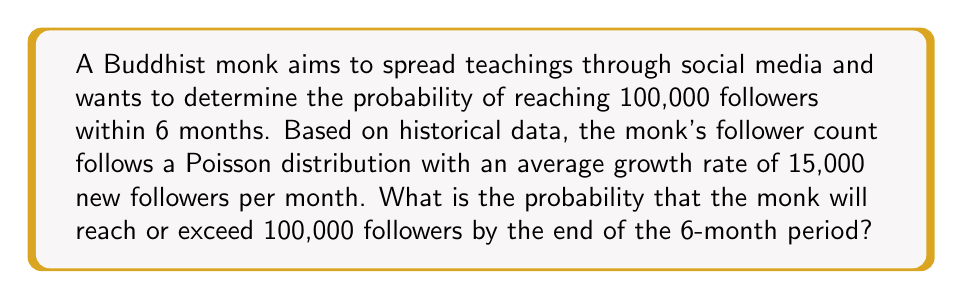Could you help me with this problem? Let's approach this step-by-step:

1) The Poisson distribution models the number of events in a fixed interval of time. In this case, we're looking at the number of new followers over 6 months.

2) The average number of new followers over 6 months is:
   $\lambda = 15,000 \times 6 = 90,000$

3) We want to find the probability of getting at least 100,000 followers. This is equivalent to finding the probability of getting 100,000 or more new followers.

4) The probability of getting exactly $k$ new followers is given by the Poisson probability mass function:

   $$P(X = k) = \frac{e^{-\lambda} \lambda^k}{k!}$$

5) We want $P(X \geq 100,000)$, which is equal to $1 - P(X < 100,000)$

6) In a Poisson distribution, $P(X < x)$ can be approximated using the normal distribution when $\lambda$ is large (which it is in this case):

   $$P(X < x) \approx \Phi(\frac{x - \lambda}{\sqrt{\lambda}})$$

   where $\Phi$ is the cumulative distribution function of the standard normal distribution.

7) In our case:

   $$P(X < 100,000) \approx \Phi(\frac{100,000 - 90,000}{\sqrt{90,000}}) = \Phi(\frac{10,000}{300}) = \Phi(33.33)$$

8) $\Phi(33.33)$ is essentially 1 in standard normal tables.

9) Therefore, $P(X \geq 100,000) = 1 - P(X < 100,000) \approx 1 - 1 = 0$
Answer: $\approx 0$ 